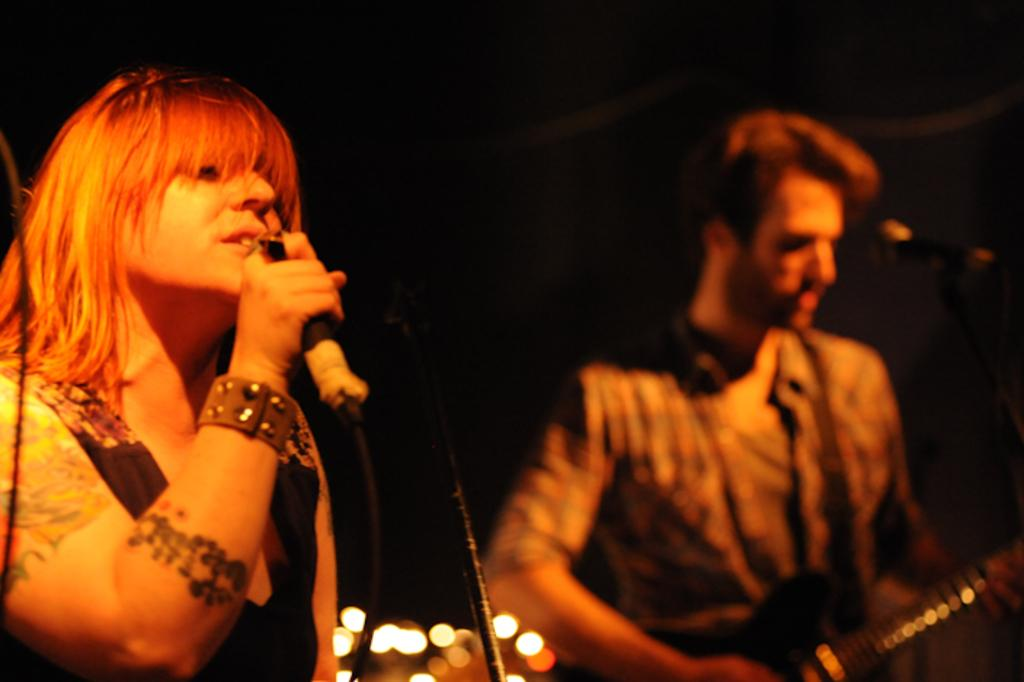What is the girl in the image doing? The girl in the image is singing. What is the girl holding while singing? The girl is holding a microphone. Can you describe the other person in the image? There is a person holding a guitar in the image. What type of trouble is the girl causing with her singing in the image? There is no indication of trouble or any negative consequences in the image; the girl is simply singing while holding a microphone. 